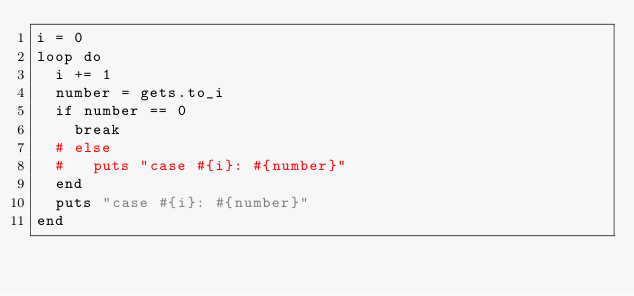Convert code to text. <code><loc_0><loc_0><loc_500><loc_500><_Ruby_>i = 0
loop do
  i += 1
  number = gets.to_i
  if number == 0
    break
  # else
  #   puts "case #{i}: #{number}"
  end
  puts "case #{i}: #{number}"
end</code> 